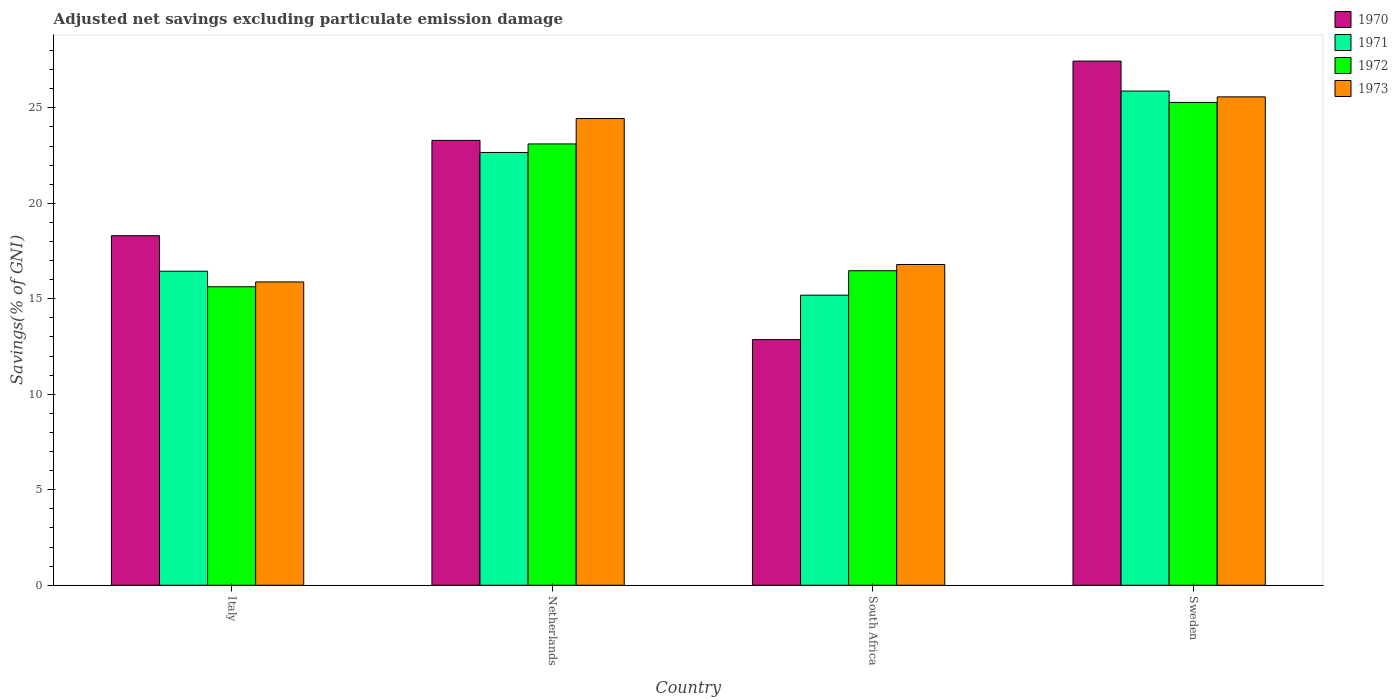Are the number of bars on each tick of the X-axis equal?
Your answer should be compact. Yes. How many bars are there on the 3rd tick from the right?
Your answer should be compact. 4. What is the label of the 1st group of bars from the left?
Keep it short and to the point. Italy. What is the adjusted net savings in 1972 in Netherlands?
Your answer should be very brief. 23.11. Across all countries, what is the maximum adjusted net savings in 1970?
Your response must be concise. 27.45. Across all countries, what is the minimum adjusted net savings in 1973?
Offer a terse response. 15.88. In which country was the adjusted net savings in 1973 maximum?
Keep it short and to the point. Sweden. In which country was the adjusted net savings in 1973 minimum?
Ensure brevity in your answer.  Italy. What is the total adjusted net savings in 1970 in the graph?
Your response must be concise. 81.91. What is the difference between the adjusted net savings in 1971 in Italy and that in South Africa?
Provide a short and direct response. 1.25. What is the difference between the adjusted net savings in 1972 in South Africa and the adjusted net savings in 1973 in Netherlands?
Your answer should be very brief. -7.97. What is the average adjusted net savings in 1973 per country?
Give a very brief answer. 20.67. What is the difference between the adjusted net savings of/in 1971 and adjusted net savings of/in 1970 in Netherlands?
Provide a short and direct response. -0.63. What is the ratio of the adjusted net savings in 1972 in Italy to that in Netherlands?
Your response must be concise. 0.68. Is the adjusted net savings in 1973 in Netherlands less than that in South Africa?
Ensure brevity in your answer.  No. What is the difference between the highest and the second highest adjusted net savings in 1971?
Provide a short and direct response. -9.43. What is the difference between the highest and the lowest adjusted net savings in 1973?
Make the answer very short. 9.69. Is the sum of the adjusted net savings in 1972 in Italy and Sweden greater than the maximum adjusted net savings in 1973 across all countries?
Your answer should be very brief. Yes. What does the 4th bar from the left in Italy represents?
Offer a very short reply. 1973. What does the 2nd bar from the right in South Africa represents?
Provide a short and direct response. 1972. Is it the case that in every country, the sum of the adjusted net savings in 1972 and adjusted net savings in 1970 is greater than the adjusted net savings in 1971?
Provide a short and direct response. Yes. How many bars are there?
Provide a short and direct response. 16. Are all the bars in the graph horizontal?
Provide a succinct answer. No. What is the difference between two consecutive major ticks on the Y-axis?
Provide a succinct answer. 5. Are the values on the major ticks of Y-axis written in scientific E-notation?
Offer a terse response. No. Does the graph contain grids?
Your answer should be very brief. No. Where does the legend appear in the graph?
Offer a terse response. Top right. How many legend labels are there?
Offer a terse response. 4. What is the title of the graph?
Ensure brevity in your answer.  Adjusted net savings excluding particulate emission damage. Does "2014" appear as one of the legend labels in the graph?
Your answer should be compact. No. What is the label or title of the X-axis?
Offer a very short reply. Country. What is the label or title of the Y-axis?
Provide a succinct answer. Savings(% of GNI). What is the Savings(% of GNI) in 1970 in Italy?
Your answer should be very brief. 18.3. What is the Savings(% of GNI) of 1971 in Italy?
Make the answer very short. 16.44. What is the Savings(% of GNI) of 1972 in Italy?
Ensure brevity in your answer.  15.63. What is the Savings(% of GNI) in 1973 in Italy?
Keep it short and to the point. 15.88. What is the Savings(% of GNI) in 1970 in Netherlands?
Make the answer very short. 23.3. What is the Savings(% of GNI) in 1971 in Netherlands?
Give a very brief answer. 22.66. What is the Savings(% of GNI) in 1972 in Netherlands?
Keep it short and to the point. 23.11. What is the Savings(% of GNI) in 1973 in Netherlands?
Your answer should be very brief. 24.44. What is the Savings(% of GNI) of 1970 in South Africa?
Provide a succinct answer. 12.86. What is the Savings(% of GNI) in 1971 in South Africa?
Your answer should be very brief. 15.19. What is the Savings(% of GNI) of 1972 in South Africa?
Ensure brevity in your answer.  16.47. What is the Savings(% of GNI) in 1973 in South Africa?
Offer a terse response. 16.8. What is the Savings(% of GNI) of 1970 in Sweden?
Provide a short and direct response. 27.45. What is the Savings(% of GNI) in 1971 in Sweden?
Keep it short and to the point. 25.88. What is the Savings(% of GNI) in 1972 in Sweden?
Your answer should be very brief. 25.28. What is the Savings(% of GNI) in 1973 in Sweden?
Provide a succinct answer. 25.57. Across all countries, what is the maximum Savings(% of GNI) in 1970?
Your answer should be compact. 27.45. Across all countries, what is the maximum Savings(% of GNI) of 1971?
Offer a terse response. 25.88. Across all countries, what is the maximum Savings(% of GNI) in 1972?
Ensure brevity in your answer.  25.28. Across all countries, what is the maximum Savings(% of GNI) of 1973?
Provide a short and direct response. 25.57. Across all countries, what is the minimum Savings(% of GNI) of 1970?
Your answer should be very brief. 12.86. Across all countries, what is the minimum Savings(% of GNI) of 1971?
Give a very brief answer. 15.19. Across all countries, what is the minimum Savings(% of GNI) in 1972?
Provide a short and direct response. 15.63. Across all countries, what is the minimum Savings(% of GNI) in 1973?
Keep it short and to the point. 15.88. What is the total Savings(% of GNI) of 1970 in the graph?
Your answer should be very brief. 81.91. What is the total Savings(% of GNI) in 1971 in the graph?
Your answer should be compact. 80.18. What is the total Savings(% of GNI) in 1972 in the graph?
Ensure brevity in your answer.  80.49. What is the total Savings(% of GNI) of 1973 in the graph?
Your response must be concise. 82.69. What is the difference between the Savings(% of GNI) of 1970 in Italy and that in Netherlands?
Make the answer very short. -4.99. What is the difference between the Savings(% of GNI) in 1971 in Italy and that in Netherlands?
Make the answer very short. -6.22. What is the difference between the Savings(% of GNI) in 1972 in Italy and that in Netherlands?
Provide a succinct answer. -7.48. What is the difference between the Savings(% of GNI) of 1973 in Italy and that in Netherlands?
Your answer should be compact. -8.56. What is the difference between the Savings(% of GNI) in 1970 in Italy and that in South Africa?
Your answer should be compact. 5.44. What is the difference between the Savings(% of GNI) of 1971 in Italy and that in South Africa?
Provide a short and direct response. 1.25. What is the difference between the Savings(% of GNI) in 1972 in Italy and that in South Africa?
Ensure brevity in your answer.  -0.84. What is the difference between the Savings(% of GNI) in 1973 in Italy and that in South Africa?
Offer a very short reply. -0.91. What is the difference between the Savings(% of GNI) in 1970 in Italy and that in Sweden?
Your response must be concise. -9.14. What is the difference between the Savings(% of GNI) of 1971 in Italy and that in Sweden?
Make the answer very short. -9.43. What is the difference between the Savings(% of GNI) of 1972 in Italy and that in Sweden?
Make the answer very short. -9.65. What is the difference between the Savings(% of GNI) in 1973 in Italy and that in Sweden?
Make the answer very short. -9.69. What is the difference between the Savings(% of GNI) of 1970 in Netherlands and that in South Africa?
Offer a terse response. 10.43. What is the difference between the Savings(% of GNI) of 1971 in Netherlands and that in South Africa?
Give a very brief answer. 7.47. What is the difference between the Savings(% of GNI) of 1972 in Netherlands and that in South Africa?
Provide a succinct answer. 6.64. What is the difference between the Savings(% of GNI) in 1973 in Netherlands and that in South Africa?
Offer a very short reply. 7.64. What is the difference between the Savings(% of GNI) of 1970 in Netherlands and that in Sweden?
Make the answer very short. -4.15. What is the difference between the Savings(% of GNI) in 1971 in Netherlands and that in Sweden?
Keep it short and to the point. -3.21. What is the difference between the Savings(% of GNI) of 1972 in Netherlands and that in Sweden?
Provide a succinct answer. -2.17. What is the difference between the Savings(% of GNI) of 1973 in Netherlands and that in Sweden?
Ensure brevity in your answer.  -1.14. What is the difference between the Savings(% of GNI) of 1970 in South Africa and that in Sweden?
Your answer should be very brief. -14.59. What is the difference between the Savings(% of GNI) in 1971 in South Africa and that in Sweden?
Provide a succinct answer. -10.69. What is the difference between the Savings(% of GNI) in 1972 in South Africa and that in Sweden?
Make the answer very short. -8.81. What is the difference between the Savings(% of GNI) in 1973 in South Africa and that in Sweden?
Your answer should be compact. -8.78. What is the difference between the Savings(% of GNI) in 1970 in Italy and the Savings(% of GNI) in 1971 in Netherlands?
Offer a terse response. -4.36. What is the difference between the Savings(% of GNI) of 1970 in Italy and the Savings(% of GNI) of 1972 in Netherlands?
Offer a very short reply. -4.81. What is the difference between the Savings(% of GNI) in 1970 in Italy and the Savings(% of GNI) in 1973 in Netherlands?
Keep it short and to the point. -6.13. What is the difference between the Savings(% of GNI) in 1971 in Italy and the Savings(% of GNI) in 1972 in Netherlands?
Your answer should be compact. -6.67. What is the difference between the Savings(% of GNI) in 1971 in Italy and the Savings(% of GNI) in 1973 in Netherlands?
Offer a very short reply. -7.99. What is the difference between the Savings(% of GNI) in 1972 in Italy and the Savings(% of GNI) in 1973 in Netherlands?
Your response must be concise. -8.81. What is the difference between the Savings(% of GNI) in 1970 in Italy and the Savings(% of GNI) in 1971 in South Africa?
Give a very brief answer. 3.11. What is the difference between the Savings(% of GNI) in 1970 in Italy and the Savings(% of GNI) in 1972 in South Africa?
Give a very brief answer. 1.83. What is the difference between the Savings(% of GNI) of 1970 in Italy and the Savings(% of GNI) of 1973 in South Africa?
Give a very brief answer. 1.51. What is the difference between the Savings(% of GNI) of 1971 in Italy and the Savings(% of GNI) of 1972 in South Africa?
Provide a short and direct response. -0.03. What is the difference between the Savings(% of GNI) of 1971 in Italy and the Savings(% of GNI) of 1973 in South Africa?
Make the answer very short. -0.35. What is the difference between the Savings(% of GNI) in 1972 in Italy and the Savings(% of GNI) in 1973 in South Africa?
Provide a short and direct response. -1.17. What is the difference between the Savings(% of GNI) of 1970 in Italy and the Savings(% of GNI) of 1971 in Sweden?
Your response must be concise. -7.57. What is the difference between the Savings(% of GNI) in 1970 in Italy and the Savings(% of GNI) in 1972 in Sweden?
Make the answer very short. -6.98. What is the difference between the Savings(% of GNI) in 1970 in Italy and the Savings(% of GNI) in 1973 in Sweden?
Make the answer very short. -7.27. What is the difference between the Savings(% of GNI) of 1971 in Italy and the Savings(% of GNI) of 1972 in Sweden?
Provide a short and direct response. -8.84. What is the difference between the Savings(% of GNI) of 1971 in Italy and the Savings(% of GNI) of 1973 in Sweden?
Provide a succinct answer. -9.13. What is the difference between the Savings(% of GNI) in 1972 in Italy and the Savings(% of GNI) in 1973 in Sweden?
Ensure brevity in your answer.  -9.94. What is the difference between the Savings(% of GNI) of 1970 in Netherlands and the Savings(% of GNI) of 1971 in South Africa?
Provide a succinct answer. 8.11. What is the difference between the Savings(% of GNI) in 1970 in Netherlands and the Savings(% of GNI) in 1972 in South Africa?
Provide a short and direct response. 6.83. What is the difference between the Savings(% of GNI) in 1970 in Netherlands and the Savings(% of GNI) in 1973 in South Africa?
Offer a terse response. 6.5. What is the difference between the Savings(% of GNI) in 1971 in Netherlands and the Savings(% of GNI) in 1972 in South Africa?
Provide a succinct answer. 6.19. What is the difference between the Savings(% of GNI) of 1971 in Netherlands and the Savings(% of GNI) of 1973 in South Africa?
Make the answer very short. 5.87. What is the difference between the Savings(% of GNI) of 1972 in Netherlands and the Savings(% of GNI) of 1973 in South Africa?
Offer a very short reply. 6.31. What is the difference between the Savings(% of GNI) of 1970 in Netherlands and the Savings(% of GNI) of 1971 in Sweden?
Provide a succinct answer. -2.58. What is the difference between the Savings(% of GNI) in 1970 in Netherlands and the Savings(% of GNI) in 1972 in Sweden?
Make the answer very short. -1.99. What is the difference between the Savings(% of GNI) in 1970 in Netherlands and the Savings(% of GNI) in 1973 in Sweden?
Provide a short and direct response. -2.28. What is the difference between the Savings(% of GNI) of 1971 in Netherlands and the Savings(% of GNI) of 1972 in Sweden?
Offer a terse response. -2.62. What is the difference between the Savings(% of GNI) of 1971 in Netherlands and the Savings(% of GNI) of 1973 in Sweden?
Make the answer very short. -2.91. What is the difference between the Savings(% of GNI) of 1972 in Netherlands and the Savings(% of GNI) of 1973 in Sweden?
Ensure brevity in your answer.  -2.46. What is the difference between the Savings(% of GNI) of 1970 in South Africa and the Savings(% of GNI) of 1971 in Sweden?
Your answer should be very brief. -13.02. What is the difference between the Savings(% of GNI) of 1970 in South Africa and the Savings(% of GNI) of 1972 in Sweden?
Ensure brevity in your answer.  -12.42. What is the difference between the Savings(% of GNI) of 1970 in South Africa and the Savings(% of GNI) of 1973 in Sweden?
Give a very brief answer. -12.71. What is the difference between the Savings(% of GNI) in 1971 in South Africa and the Savings(% of GNI) in 1972 in Sweden?
Your answer should be compact. -10.09. What is the difference between the Savings(% of GNI) of 1971 in South Africa and the Savings(% of GNI) of 1973 in Sweden?
Your answer should be compact. -10.38. What is the difference between the Savings(% of GNI) in 1972 in South Africa and the Savings(% of GNI) in 1973 in Sweden?
Offer a very short reply. -9.1. What is the average Savings(% of GNI) of 1970 per country?
Your answer should be very brief. 20.48. What is the average Savings(% of GNI) in 1971 per country?
Provide a short and direct response. 20.04. What is the average Savings(% of GNI) in 1972 per country?
Provide a succinct answer. 20.12. What is the average Savings(% of GNI) in 1973 per country?
Your response must be concise. 20.67. What is the difference between the Savings(% of GNI) of 1970 and Savings(% of GNI) of 1971 in Italy?
Offer a very short reply. 1.86. What is the difference between the Savings(% of GNI) in 1970 and Savings(% of GNI) in 1972 in Italy?
Provide a short and direct response. 2.67. What is the difference between the Savings(% of GNI) in 1970 and Savings(% of GNI) in 1973 in Italy?
Offer a very short reply. 2.42. What is the difference between the Savings(% of GNI) in 1971 and Savings(% of GNI) in 1972 in Italy?
Offer a terse response. 0.81. What is the difference between the Savings(% of GNI) in 1971 and Savings(% of GNI) in 1973 in Italy?
Give a very brief answer. 0.56. What is the difference between the Savings(% of GNI) in 1972 and Savings(% of GNI) in 1973 in Italy?
Keep it short and to the point. -0.25. What is the difference between the Savings(% of GNI) of 1970 and Savings(% of GNI) of 1971 in Netherlands?
Your answer should be compact. 0.63. What is the difference between the Savings(% of GNI) in 1970 and Savings(% of GNI) in 1972 in Netherlands?
Provide a short and direct response. 0.19. What is the difference between the Savings(% of GNI) in 1970 and Savings(% of GNI) in 1973 in Netherlands?
Give a very brief answer. -1.14. What is the difference between the Savings(% of GNI) of 1971 and Savings(% of GNI) of 1972 in Netherlands?
Give a very brief answer. -0.45. What is the difference between the Savings(% of GNI) of 1971 and Savings(% of GNI) of 1973 in Netherlands?
Make the answer very short. -1.77. What is the difference between the Savings(% of GNI) of 1972 and Savings(% of GNI) of 1973 in Netherlands?
Offer a very short reply. -1.33. What is the difference between the Savings(% of GNI) of 1970 and Savings(% of GNI) of 1971 in South Africa?
Give a very brief answer. -2.33. What is the difference between the Savings(% of GNI) in 1970 and Savings(% of GNI) in 1972 in South Africa?
Make the answer very short. -3.61. What is the difference between the Savings(% of GNI) in 1970 and Savings(% of GNI) in 1973 in South Africa?
Your response must be concise. -3.93. What is the difference between the Savings(% of GNI) of 1971 and Savings(% of GNI) of 1972 in South Africa?
Make the answer very short. -1.28. What is the difference between the Savings(% of GNI) of 1971 and Savings(% of GNI) of 1973 in South Africa?
Give a very brief answer. -1.61. What is the difference between the Savings(% of GNI) in 1972 and Savings(% of GNI) in 1973 in South Africa?
Provide a short and direct response. -0.33. What is the difference between the Savings(% of GNI) of 1970 and Savings(% of GNI) of 1971 in Sweden?
Provide a short and direct response. 1.57. What is the difference between the Savings(% of GNI) in 1970 and Savings(% of GNI) in 1972 in Sweden?
Ensure brevity in your answer.  2.16. What is the difference between the Savings(% of GNI) in 1970 and Savings(% of GNI) in 1973 in Sweden?
Keep it short and to the point. 1.87. What is the difference between the Savings(% of GNI) of 1971 and Savings(% of GNI) of 1972 in Sweden?
Provide a succinct answer. 0.59. What is the difference between the Savings(% of GNI) of 1971 and Savings(% of GNI) of 1973 in Sweden?
Your answer should be compact. 0.3. What is the difference between the Savings(% of GNI) of 1972 and Savings(% of GNI) of 1973 in Sweden?
Give a very brief answer. -0.29. What is the ratio of the Savings(% of GNI) in 1970 in Italy to that in Netherlands?
Make the answer very short. 0.79. What is the ratio of the Savings(% of GNI) of 1971 in Italy to that in Netherlands?
Provide a short and direct response. 0.73. What is the ratio of the Savings(% of GNI) in 1972 in Italy to that in Netherlands?
Provide a succinct answer. 0.68. What is the ratio of the Savings(% of GNI) in 1973 in Italy to that in Netherlands?
Offer a terse response. 0.65. What is the ratio of the Savings(% of GNI) of 1970 in Italy to that in South Africa?
Give a very brief answer. 1.42. What is the ratio of the Savings(% of GNI) in 1971 in Italy to that in South Africa?
Offer a very short reply. 1.08. What is the ratio of the Savings(% of GNI) of 1972 in Italy to that in South Africa?
Provide a short and direct response. 0.95. What is the ratio of the Savings(% of GNI) in 1973 in Italy to that in South Africa?
Provide a succinct answer. 0.95. What is the ratio of the Savings(% of GNI) in 1970 in Italy to that in Sweden?
Your answer should be compact. 0.67. What is the ratio of the Savings(% of GNI) of 1971 in Italy to that in Sweden?
Ensure brevity in your answer.  0.64. What is the ratio of the Savings(% of GNI) of 1972 in Italy to that in Sweden?
Your response must be concise. 0.62. What is the ratio of the Savings(% of GNI) of 1973 in Italy to that in Sweden?
Give a very brief answer. 0.62. What is the ratio of the Savings(% of GNI) in 1970 in Netherlands to that in South Africa?
Offer a terse response. 1.81. What is the ratio of the Savings(% of GNI) in 1971 in Netherlands to that in South Africa?
Give a very brief answer. 1.49. What is the ratio of the Savings(% of GNI) of 1972 in Netherlands to that in South Africa?
Provide a short and direct response. 1.4. What is the ratio of the Savings(% of GNI) in 1973 in Netherlands to that in South Africa?
Your response must be concise. 1.46. What is the ratio of the Savings(% of GNI) in 1970 in Netherlands to that in Sweden?
Offer a terse response. 0.85. What is the ratio of the Savings(% of GNI) in 1971 in Netherlands to that in Sweden?
Provide a short and direct response. 0.88. What is the ratio of the Savings(% of GNI) in 1972 in Netherlands to that in Sweden?
Give a very brief answer. 0.91. What is the ratio of the Savings(% of GNI) of 1973 in Netherlands to that in Sweden?
Provide a short and direct response. 0.96. What is the ratio of the Savings(% of GNI) of 1970 in South Africa to that in Sweden?
Your response must be concise. 0.47. What is the ratio of the Savings(% of GNI) of 1971 in South Africa to that in Sweden?
Keep it short and to the point. 0.59. What is the ratio of the Savings(% of GNI) in 1972 in South Africa to that in Sweden?
Your answer should be compact. 0.65. What is the ratio of the Savings(% of GNI) of 1973 in South Africa to that in Sweden?
Your response must be concise. 0.66. What is the difference between the highest and the second highest Savings(% of GNI) of 1970?
Ensure brevity in your answer.  4.15. What is the difference between the highest and the second highest Savings(% of GNI) of 1971?
Offer a terse response. 3.21. What is the difference between the highest and the second highest Savings(% of GNI) in 1972?
Give a very brief answer. 2.17. What is the difference between the highest and the second highest Savings(% of GNI) of 1973?
Your answer should be very brief. 1.14. What is the difference between the highest and the lowest Savings(% of GNI) in 1970?
Your response must be concise. 14.59. What is the difference between the highest and the lowest Savings(% of GNI) in 1971?
Offer a terse response. 10.69. What is the difference between the highest and the lowest Savings(% of GNI) of 1972?
Offer a terse response. 9.65. What is the difference between the highest and the lowest Savings(% of GNI) of 1973?
Make the answer very short. 9.69. 